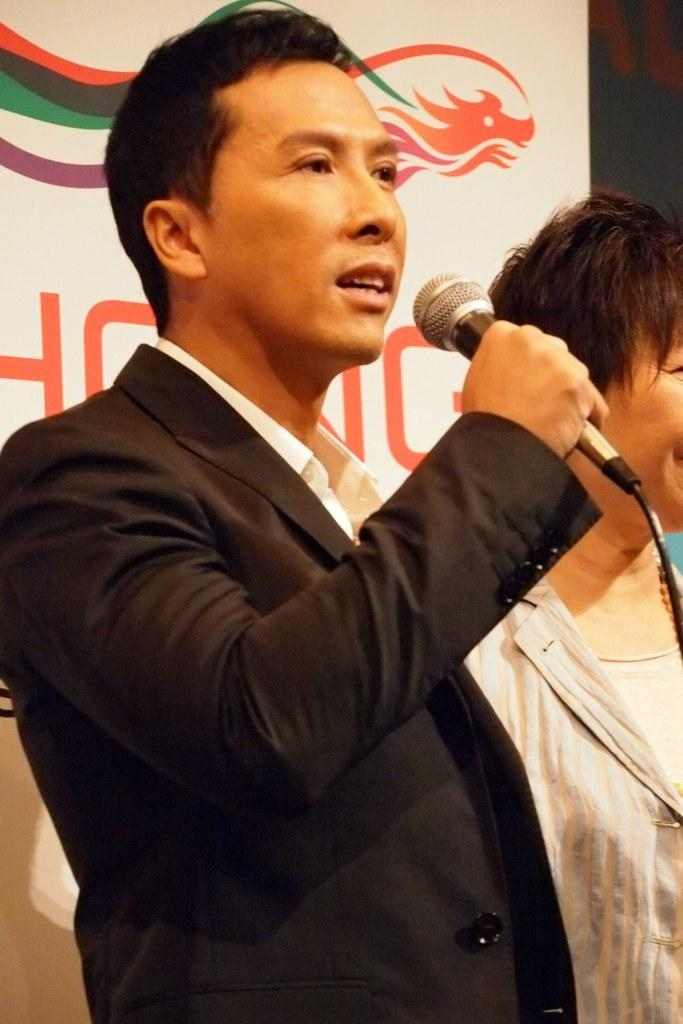How many people are present in the image? There are two people in the image. What can be seen in the background of the image? There is a white color banner in the background. What is the man in the image holding? The man is holding a mic in the image. What type of leaf is being read by the person in the image? There is no leaf present in the image, nor is anyone reading anything. 